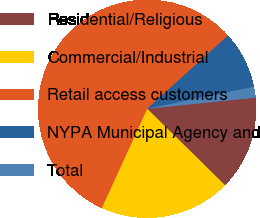Convert chart. <chart><loc_0><loc_0><loc_500><loc_500><pie_chart><fcel>Residential/Religious<fcel>Commercial/Industrial<fcel>Retail access customers<fcel>NYPA Municipal Agency and<fcel>Total<nl><fcel>13.98%<fcel>19.47%<fcel>56.47%<fcel>8.49%<fcel>1.59%<nl></chart> 